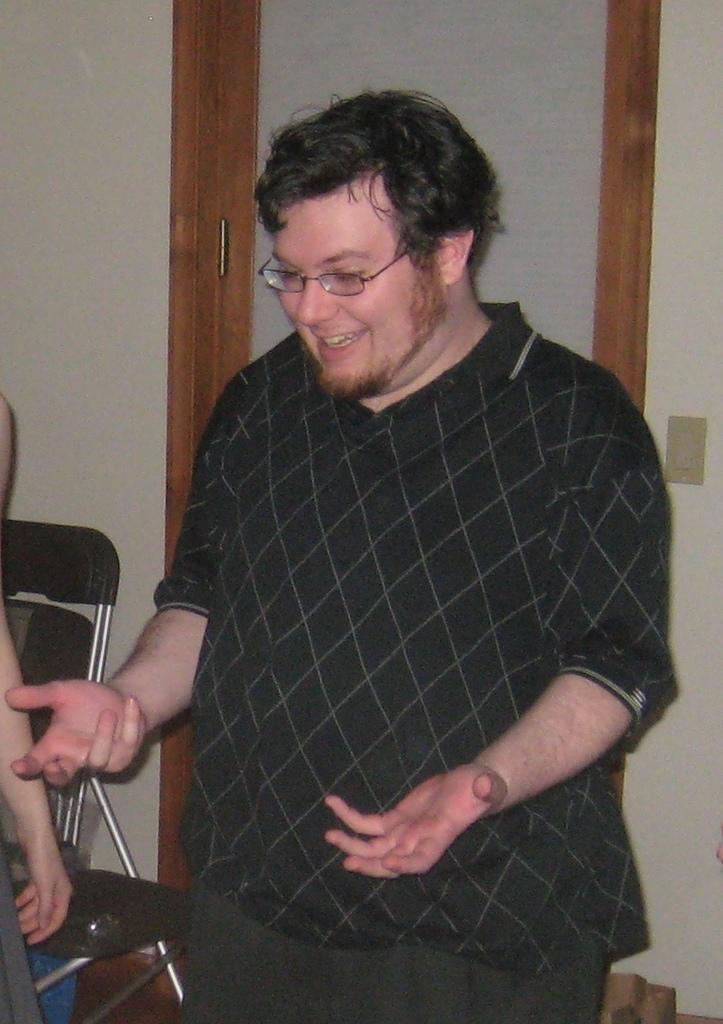Describe this image in one or two sentences. In this image the person is standing and smiling. There is a chair. 